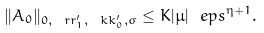Convert formula to latex. <formula><loc_0><loc_0><loc_500><loc_500>\| A _ { 0 } \| _ { 0 , \ r r _ { 1 } ^ { \prime } , \ k k _ { 0 } ^ { \prime } , \sigma } \leq K | \mu | \ e p s ^ { \eta + 1 } .</formula> 